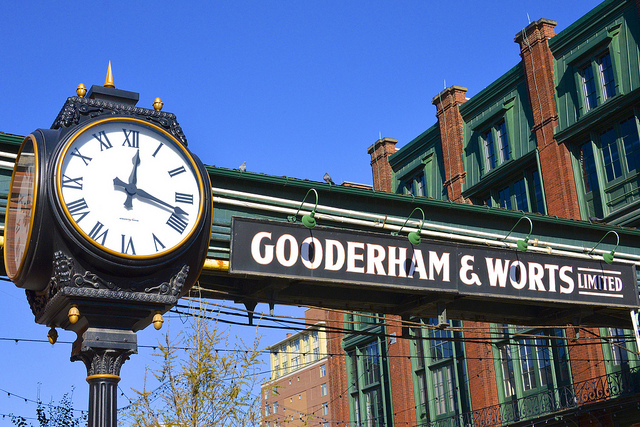Identify the text contained in this image. GOODERHAM WORTS LIMITED XI IA III II I XII IIII VII XI X E 